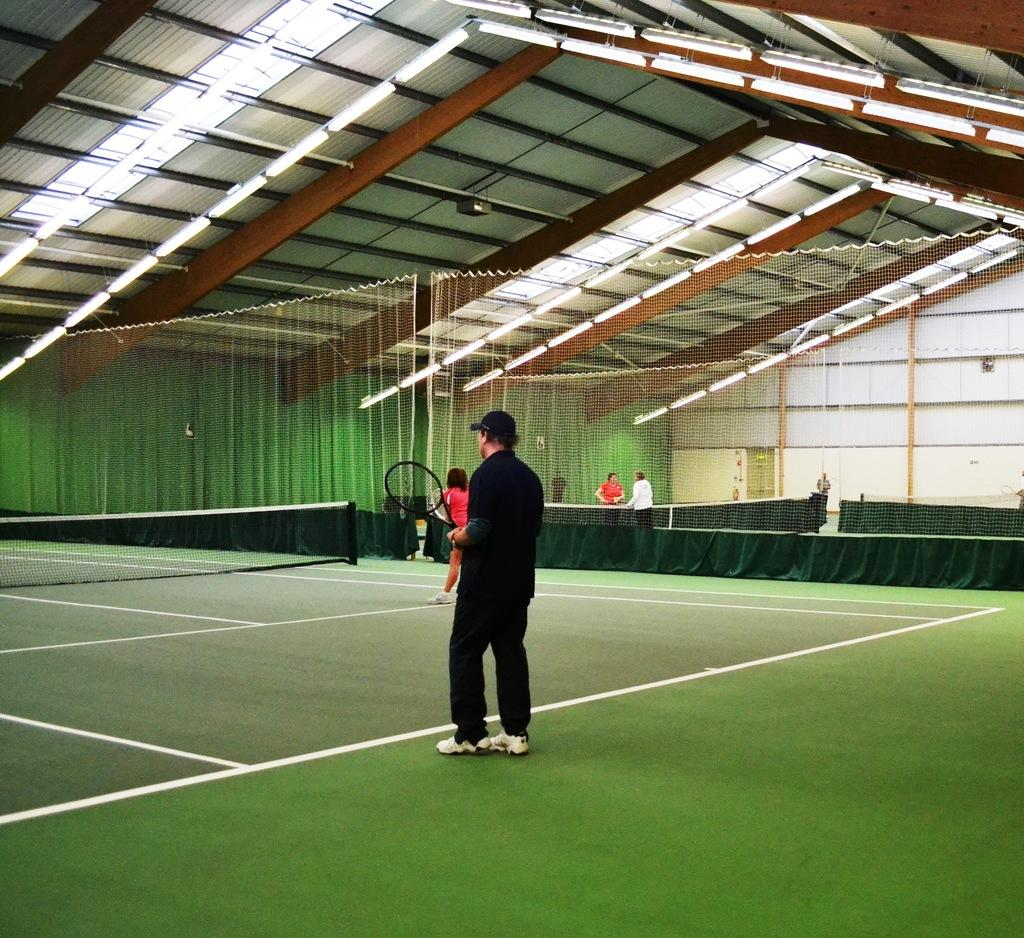What is the man in the image wearing? The man in the image is wearing a black suit. What is the man holding in the image? The man is holding a racket. What can be seen illuminating the scene in the image? There are lights visible in the image. How far away are the people from the man with the racket? There are people standing far from the man with the racket in the image. What type of insect can be seen on the racket in the image? There is no insect present in the image. 